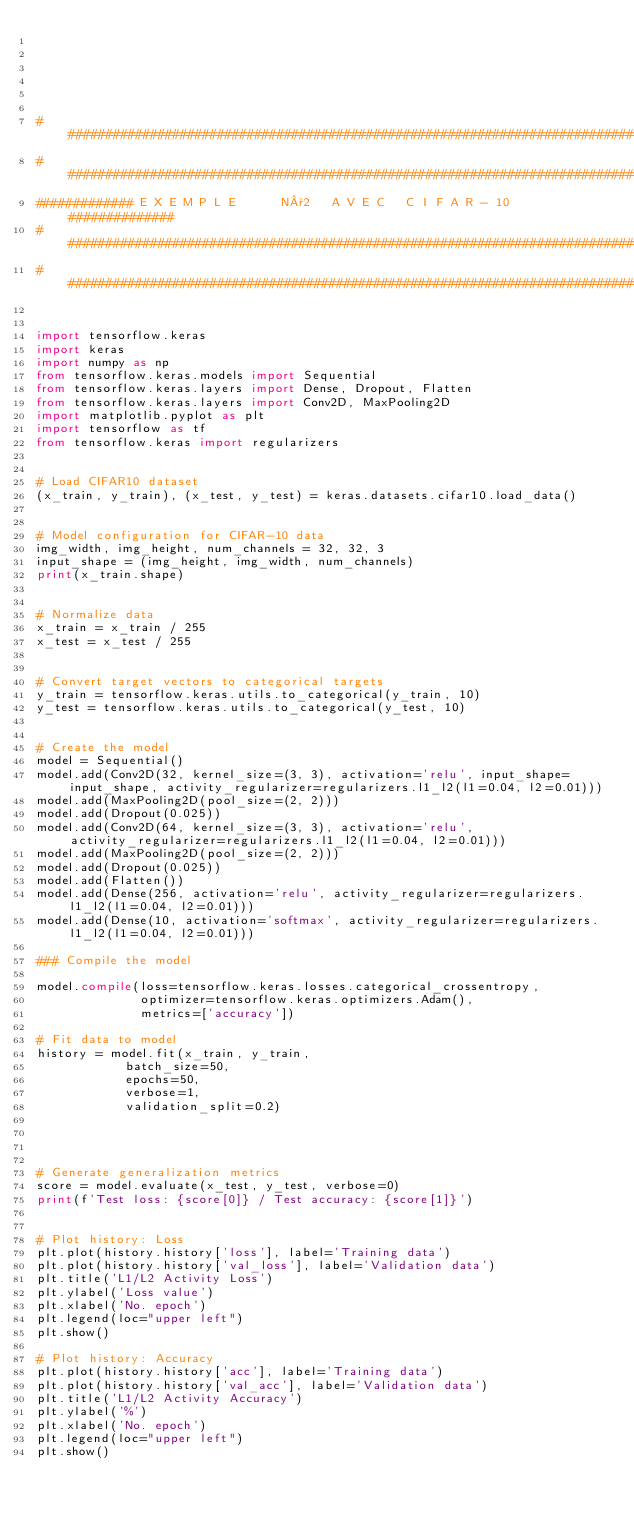<code> <loc_0><loc_0><loc_500><loc_500><_Python_>





###############################################################################
###############################################################################
############# E X E M P L E      N°2   A V E C   C I F A R - 10  ##############
###############################################################################
###############################################################################


import tensorflow.keras
import keras
import numpy as np
from tensorflow.keras.models import Sequential
from tensorflow.keras.layers import Dense, Dropout, Flatten
from tensorflow.keras.layers import Conv2D, MaxPooling2D
import matplotlib.pyplot as plt
import tensorflow as tf
from tensorflow.keras import regularizers


# Load CIFAR10 dataset
(x_train, y_train), (x_test, y_test) = keras.datasets.cifar10.load_data()


# Model configuration for CIFAR-10 data
img_width, img_height, num_channels = 32, 32, 3
input_shape = (img_height, img_width, num_channels)
print(x_train.shape)


# Normalize data
x_train = x_train / 255
x_test = x_test / 255


# Convert target vectors to categorical targets
y_train = tensorflow.keras.utils.to_categorical(y_train, 10)
y_test = tensorflow.keras.utils.to_categorical(y_test, 10)


# Create the model
model = Sequential()
model.add(Conv2D(32, kernel_size=(3, 3), activation='relu', input_shape=input_shape, activity_regularizer=regularizers.l1_l2(l1=0.04, l2=0.01)))
model.add(MaxPooling2D(pool_size=(2, 2)))
model.add(Dropout(0.025))
model.add(Conv2D(64, kernel_size=(3, 3), activation='relu', activity_regularizer=regularizers.l1_l2(l1=0.04, l2=0.01)))
model.add(MaxPooling2D(pool_size=(2, 2)))
model.add(Dropout(0.025))
model.add(Flatten())
model.add(Dense(256, activation='relu', activity_regularizer=regularizers.l1_l2(l1=0.04, l2=0.01)))
model.add(Dense(10, activation='softmax', activity_regularizer=regularizers.l1_l2(l1=0.04, l2=0.01)))

### Compile the model 

model.compile(loss=tensorflow.keras.losses.categorical_crossentropy,
              optimizer=tensorflow.keras.optimizers.Adam(),
              metrics=['accuracy'])

# Fit data to model
history = model.fit(x_train, y_train,
            batch_size=50,
            epochs=50,
            verbose=1,
            validation_split=0.2)




# Generate generalization metrics
score = model.evaluate(x_test, y_test, verbose=0)
print(f'Test loss: {score[0]} / Test accuracy: {score[1]}')


# Plot history: Loss
plt.plot(history.history['loss'], label='Training data')
plt.plot(history.history['val_loss'], label='Validation data')
plt.title('L1/L2 Activity Loss')
plt.ylabel('Loss value')
plt.xlabel('No. epoch')
plt.legend(loc="upper left")
plt.show()

# Plot history: Accuracy
plt.plot(history.history['acc'], label='Training data')
plt.plot(history.history['val_acc'], label='Validation data')
plt.title('L1/L2 Activity Accuracy')
plt.ylabel('%')
plt.xlabel('No. epoch')
plt.legend(loc="upper left")
plt.show()



















</code> 